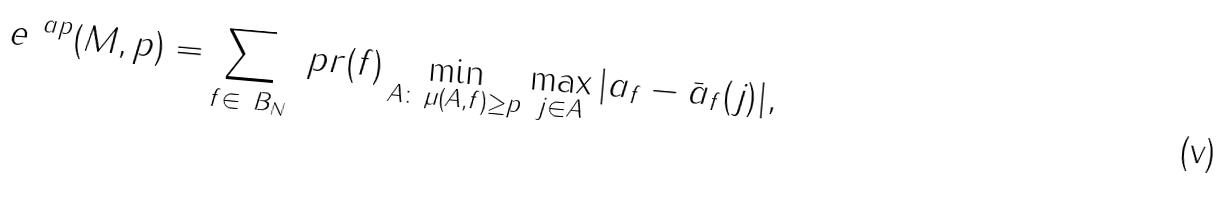Convert formula to latex. <formula><loc_0><loc_0><loc_500><loc_500>e ^ { \ a p } ( M , p ) = \sum _ { f \in \ B _ { N } } \ p r ( f ) \min _ { A \colon \, \mu ( A , f ) \geq p } \max _ { j \in A } | a _ { f } - \bar { a } _ { f } ( j ) | ,</formula> 